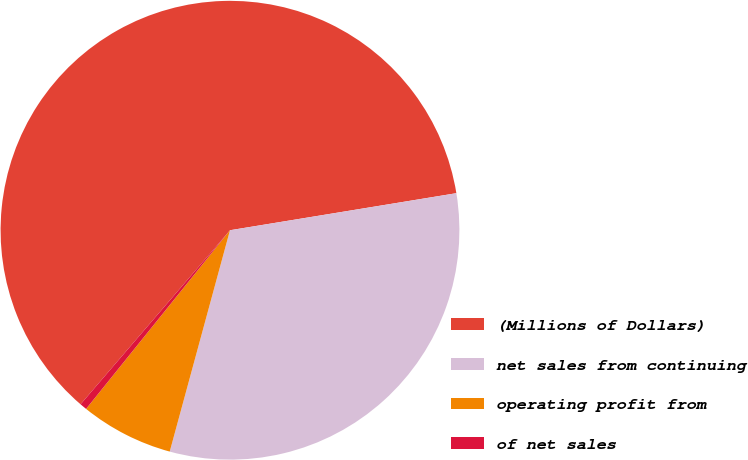Convert chart. <chart><loc_0><loc_0><loc_500><loc_500><pie_chart><fcel>(Millions of Dollars)<fcel>net sales from continuing<fcel>operating profit from<fcel>of net sales<nl><fcel>61.12%<fcel>31.81%<fcel>6.56%<fcel>0.5%<nl></chart> 